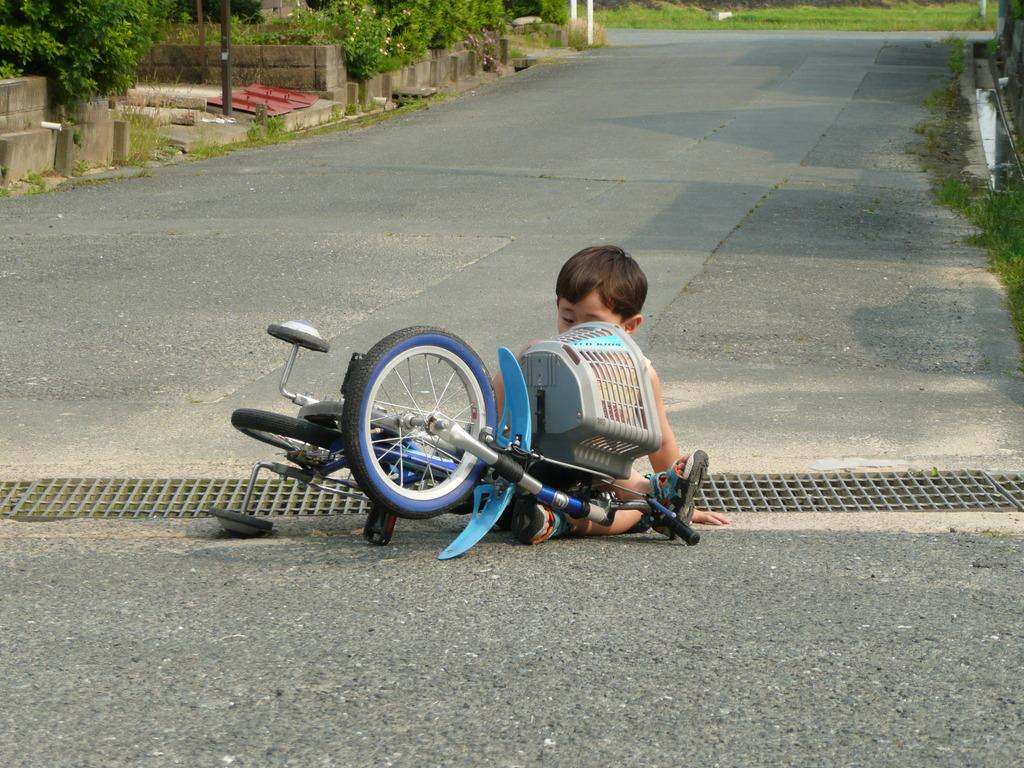What is the kid doing in the image? The kid is sitting on the road in the image. What object is present in the image that the kid might use for transportation? There is a bicycle in the image. What can be seen in the background of the image? There are plants and grass in the background of the image. What type of beef can be seen hanging from the bicycle in the image? There is no beef present in the image; it features a kid sitting on the road and a bicycle. Can you describe the bird that is perched on the plants in the background? There is no bird present in the image; it only shows plants and grass in the background. 